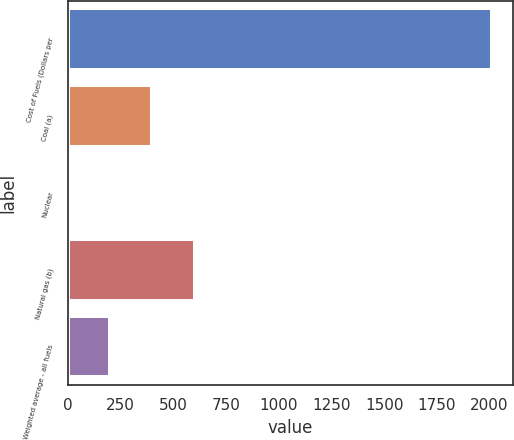Convert chart to OTSL. <chart><loc_0><loc_0><loc_500><loc_500><bar_chart><fcel>Cost of Fuels (Dollars per<fcel>Coal (a)<fcel>Nuclear<fcel>Natural gas (b)<fcel>Weighted average - all fuels<nl><fcel>2010<fcel>402.56<fcel>0.7<fcel>603.49<fcel>201.63<nl></chart> 